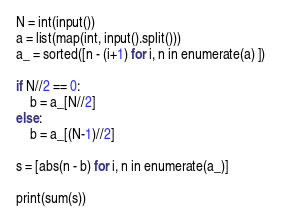Convert code to text. <code><loc_0><loc_0><loc_500><loc_500><_Python_>N = int(input())
a = list(map(int, input().split()))
a_ = sorted([n - (i+1) for i, n in enumerate(a) ])

if N//2 == 0:
    b = a_[N//2]
else:
    b = a_[(N-1)//2]

s = [abs(n - b) for i, n in enumerate(a_)]

print(sum(s))</code> 